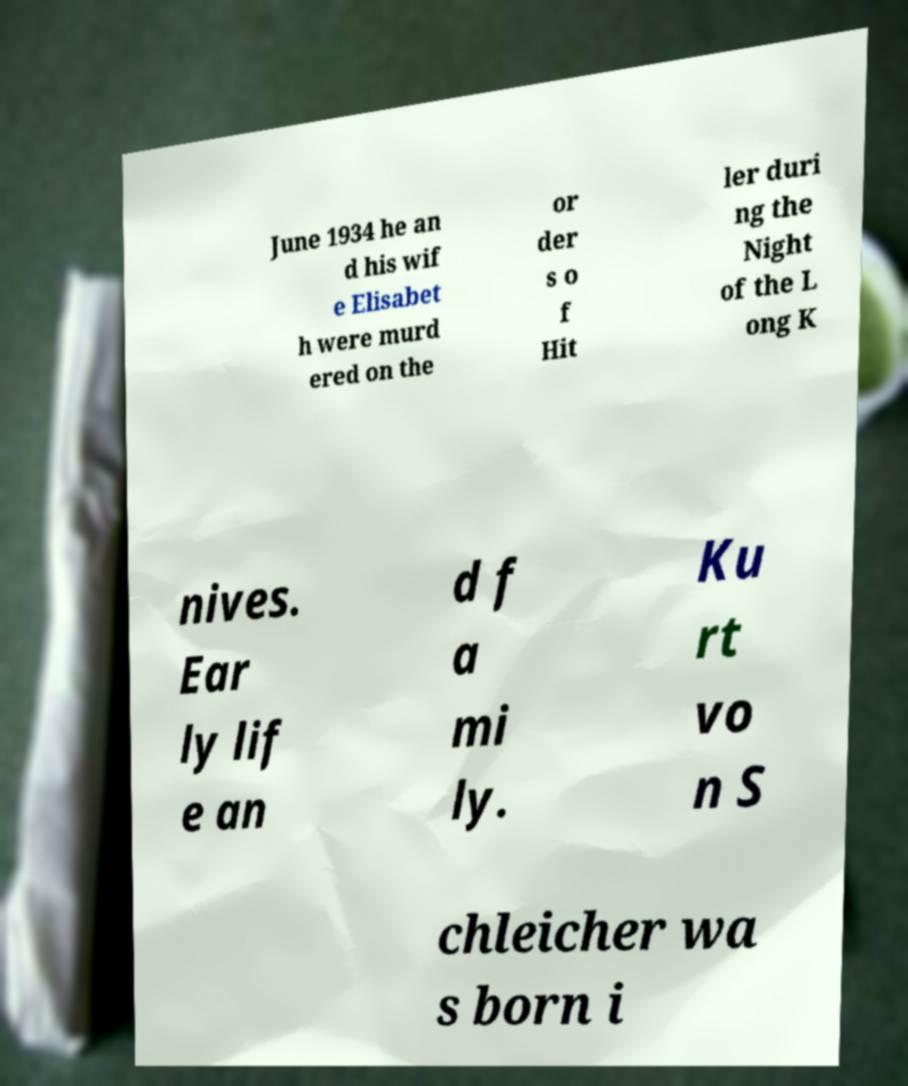I need the written content from this picture converted into text. Can you do that? June 1934 he an d his wif e Elisabet h were murd ered on the or der s o f Hit ler duri ng the Night of the L ong K nives. Ear ly lif e an d f a mi ly. Ku rt vo n S chleicher wa s born i 